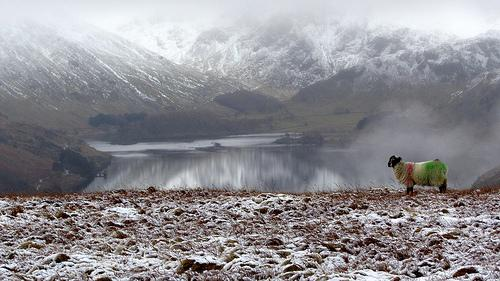Question: what is in the background?
Choices:
A. Buildings.
B. Tress.
C. Houses.
D. Mountains.
Answer with the letter. Answer: D Question: what is the animal in the photo?
Choices:
A. Horse.
B. Dog.
C. Sheep.
D. Cat.
Answer with the letter. Answer: C Question: why are there colors in the sheep's coat?
Choices:
A. From the paint.
B. From crayons.
C. Someone dyed it.
D. Naturally born that way.
Answer with the letter. Answer: C 